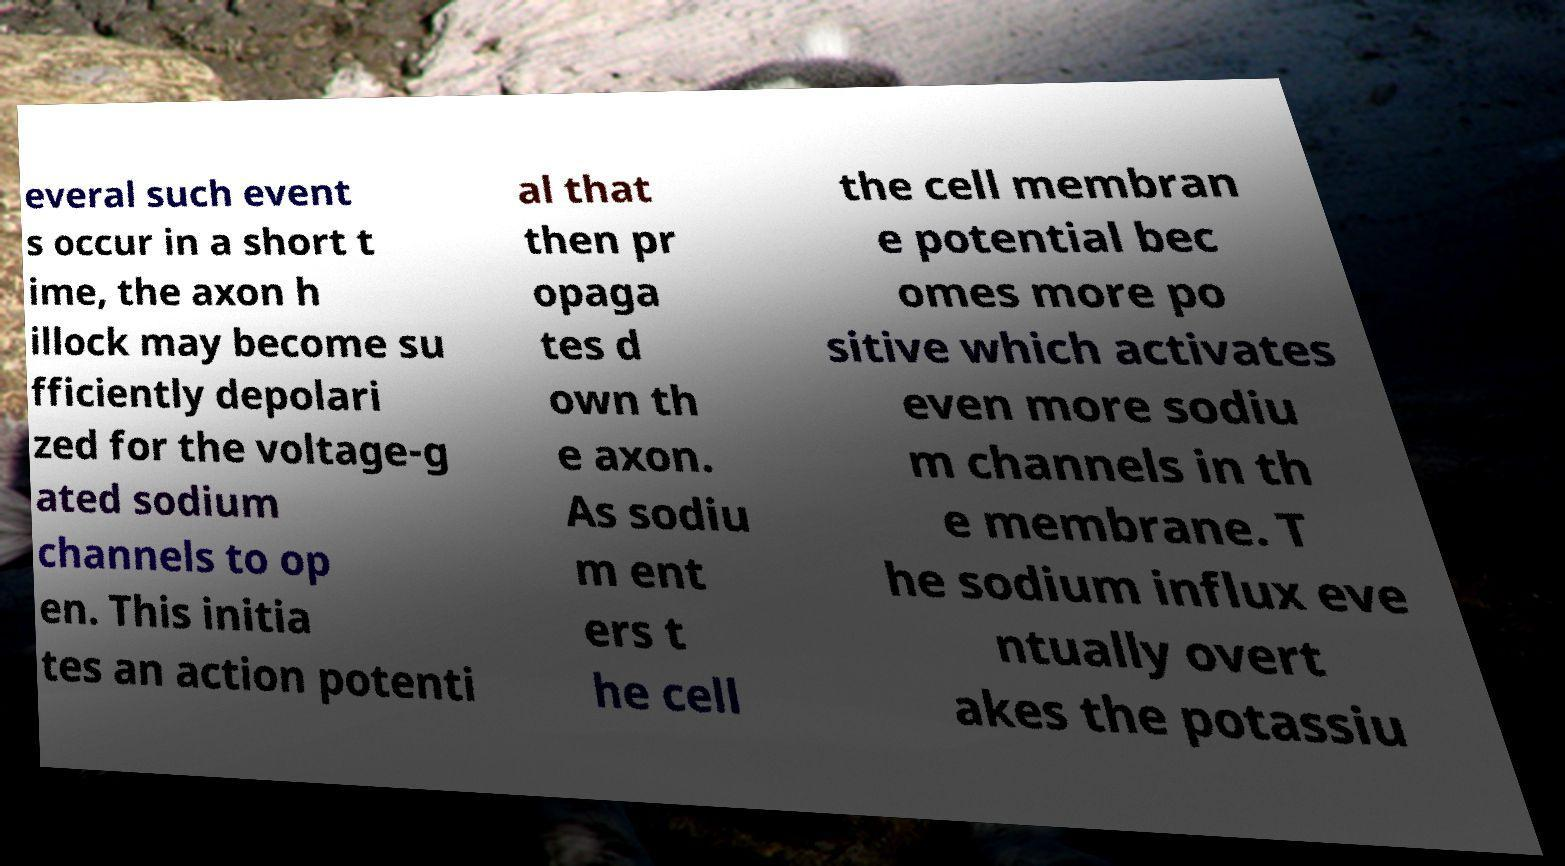Could you assist in decoding the text presented in this image and type it out clearly? everal such event s occur in a short t ime, the axon h illock may become su fficiently depolari zed for the voltage-g ated sodium channels to op en. This initia tes an action potenti al that then pr opaga tes d own th e axon. As sodiu m ent ers t he cell the cell membran e potential bec omes more po sitive which activates even more sodiu m channels in th e membrane. T he sodium influx eve ntually overt akes the potassiu 